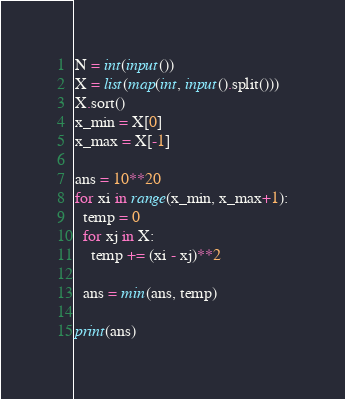Convert code to text. <code><loc_0><loc_0><loc_500><loc_500><_Python_>N = int(input())
X = list(map(int, input().split()))
X.sort()
x_min = X[0]
x_max = X[-1]

ans = 10**20
for xi in range(x_min, x_max+1):
  temp = 0
  for xj in X:
    temp += (xi - xj)**2
  
  ans = min(ans, temp)

print(ans)</code> 